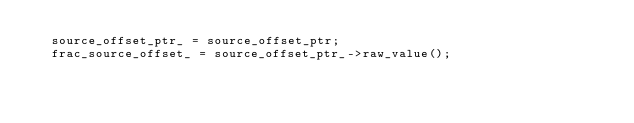Convert code to text. <code><loc_0><loc_0><loc_500><loc_500><_C++_>  source_offset_ptr_ = source_offset_ptr;
  frac_source_offset_ = source_offset_ptr_->raw_value();
</code> 